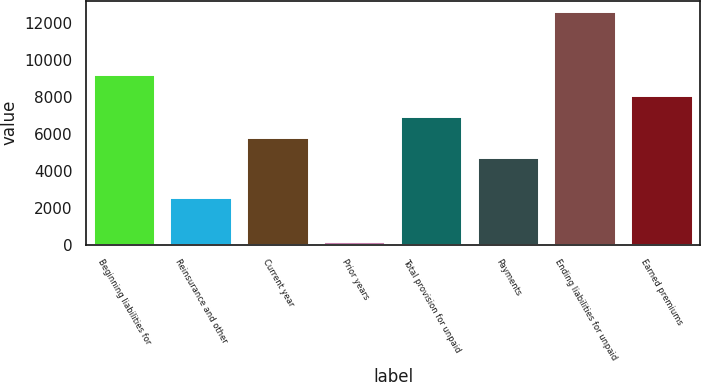<chart> <loc_0><loc_0><loc_500><loc_500><bar_chart><fcel>Beginning liabilities for<fcel>Reinsurance and other<fcel>Current year<fcel>Prior years<fcel>Total provision for unpaid<fcel>Payments<fcel>Ending liabilities for unpaid<fcel>Earned premiums<nl><fcel>9206.2<fcel>2523<fcel>5812.3<fcel>123<fcel>6943.6<fcel>4681<fcel>12600.1<fcel>8074.9<nl></chart> 